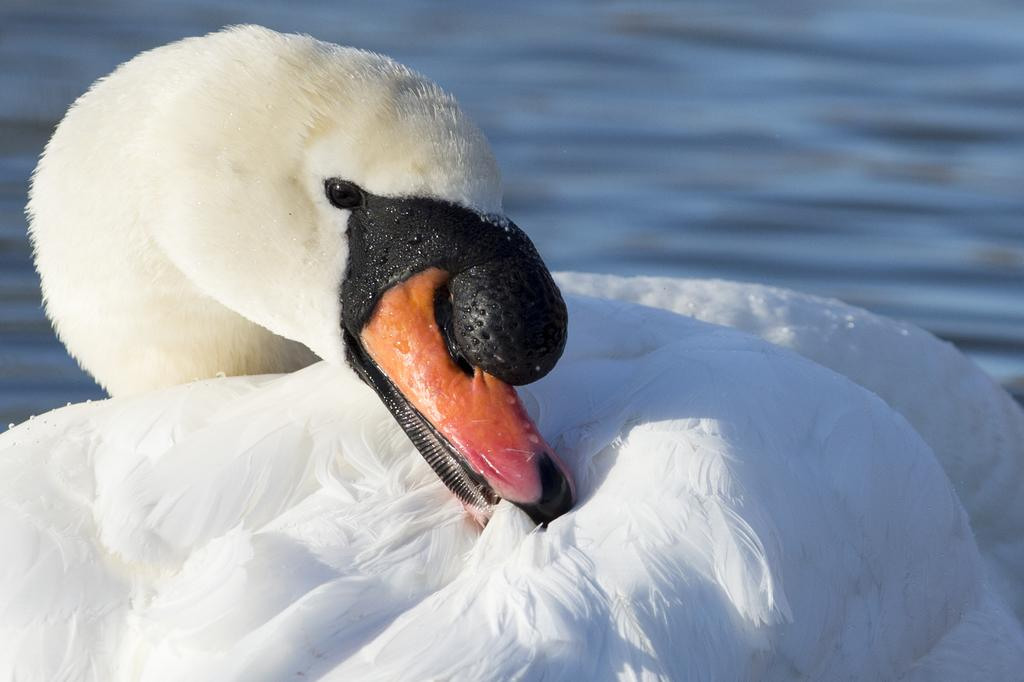What animal is present in the image? There is a swan in the image. Where is the swan located? The swan is in water. What type of celery is being used by the committee in the image? There is no celery or committee present in the image; it features a swan in water. 